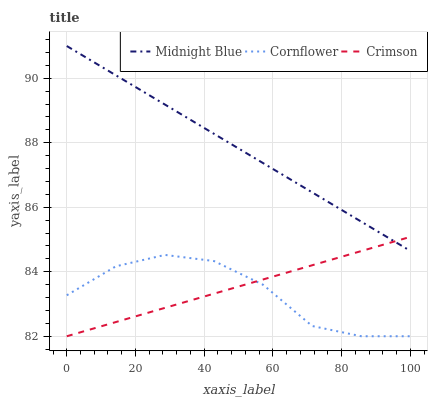Does Cornflower have the minimum area under the curve?
Answer yes or no. Yes. Does Midnight Blue have the maximum area under the curve?
Answer yes or no. Yes. Does Midnight Blue have the minimum area under the curve?
Answer yes or no. No. Does Cornflower have the maximum area under the curve?
Answer yes or no. No. Is Midnight Blue the smoothest?
Answer yes or no. Yes. Is Cornflower the roughest?
Answer yes or no. Yes. Is Cornflower the smoothest?
Answer yes or no. No. Is Midnight Blue the roughest?
Answer yes or no. No. Does Midnight Blue have the lowest value?
Answer yes or no. No. Does Midnight Blue have the highest value?
Answer yes or no. Yes. Does Cornflower have the highest value?
Answer yes or no. No. Is Cornflower less than Midnight Blue?
Answer yes or no. Yes. Is Midnight Blue greater than Cornflower?
Answer yes or no. Yes. Does Cornflower intersect Crimson?
Answer yes or no. Yes. Is Cornflower less than Crimson?
Answer yes or no. No. Is Cornflower greater than Crimson?
Answer yes or no. No. Does Cornflower intersect Midnight Blue?
Answer yes or no. No. 